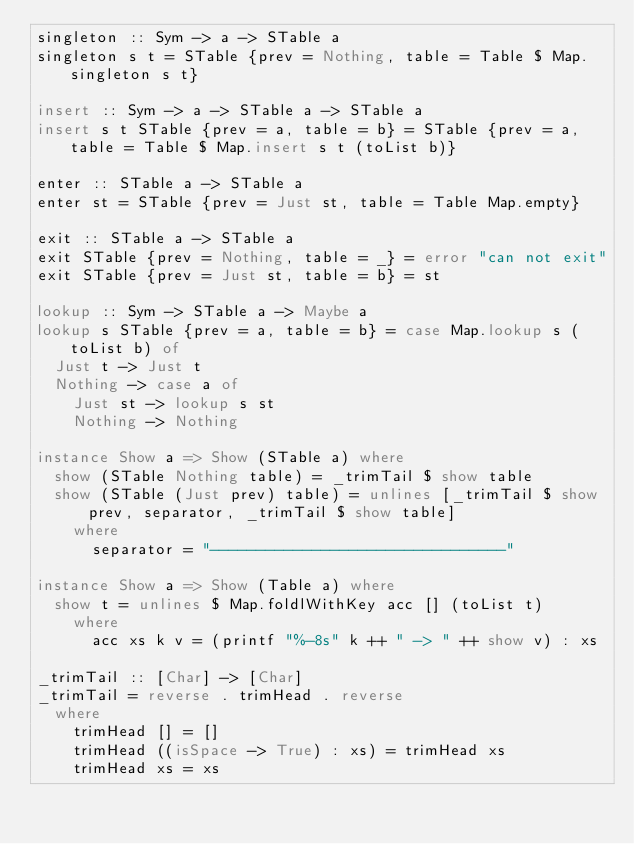Convert code to text. <code><loc_0><loc_0><loc_500><loc_500><_Haskell_>singleton :: Sym -> a -> STable a
singleton s t = STable {prev = Nothing, table = Table $ Map.singleton s t}

insert :: Sym -> a -> STable a -> STable a
insert s t STable {prev = a, table = b} = STable {prev = a, table = Table $ Map.insert s t (toList b)}

enter :: STable a -> STable a
enter st = STable {prev = Just st, table = Table Map.empty}

exit :: STable a -> STable a
exit STable {prev = Nothing, table = _} = error "can not exit"
exit STable {prev = Just st, table = b} = st

lookup :: Sym -> STable a -> Maybe a
lookup s STable {prev = a, table = b} = case Map.lookup s (toList b) of
  Just t -> Just t
  Nothing -> case a of
    Just st -> lookup s st
    Nothing -> Nothing

instance Show a => Show (STable a) where
  show (STable Nothing table) = _trimTail $ show table
  show (STable (Just prev) table) = unlines [_trimTail $ show prev, separator, _trimTail $ show table]
    where
      separator = "--------------------------------"

instance Show a => Show (Table a) where
  show t = unlines $ Map.foldlWithKey acc [] (toList t)
    where
      acc xs k v = (printf "%-8s" k ++ " -> " ++ show v) : xs

_trimTail :: [Char] -> [Char]
_trimTail = reverse . trimHead . reverse
  where
    trimHead [] = []
    trimHead ((isSpace -> True) : xs) = trimHead xs
    trimHead xs = xs</code> 